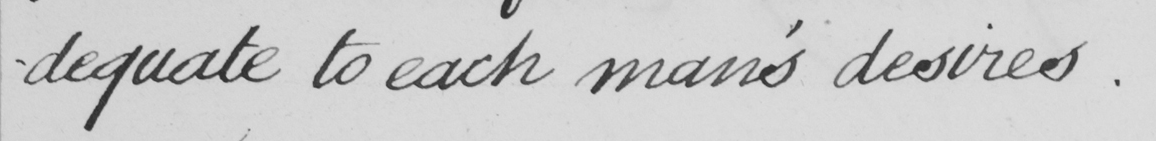Please transcribe the handwritten text in this image. -dequate  to each man's desires. 